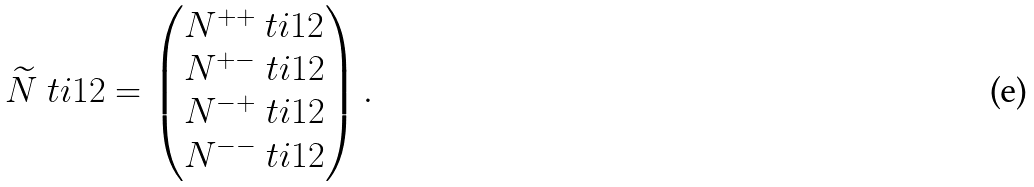Convert formula to latex. <formula><loc_0><loc_0><loc_500><loc_500>\widetilde { N } \ t i { 1 2 } = \begin{pmatrix} N ^ { + + } \ t i { 1 2 } \\ N ^ { + - } \ t i { 1 2 } \\ N ^ { - + } \ t i { 1 2 } \\ N ^ { - - } \ t i { 1 2 } \end{pmatrix} .</formula> 